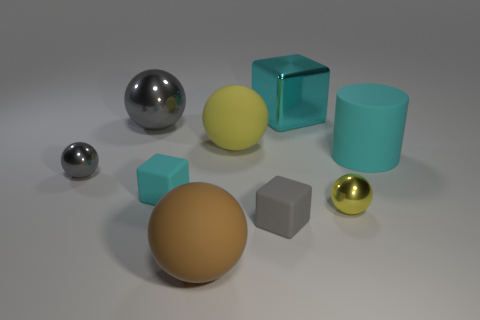Subtract all brown spheres. How many spheres are left? 4 Subtract all large brown rubber spheres. How many spheres are left? 4 Subtract 2 spheres. How many spheres are left? 3 Subtract all cyan balls. Subtract all yellow cubes. How many balls are left? 5 Add 1 gray cubes. How many objects exist? 10 Subtract all cubes. How many objects are left? 6 Subtract 0 purple cubes. How many objects are left? 9 Subtract all tiny gray cubes. Subtract all red matte cylinders. How many objects are left? 8 Add 4 small gray things. How many small gray things are left? 6 Add 4 purple metallic objects. How many purple metallic objects exist? 4 